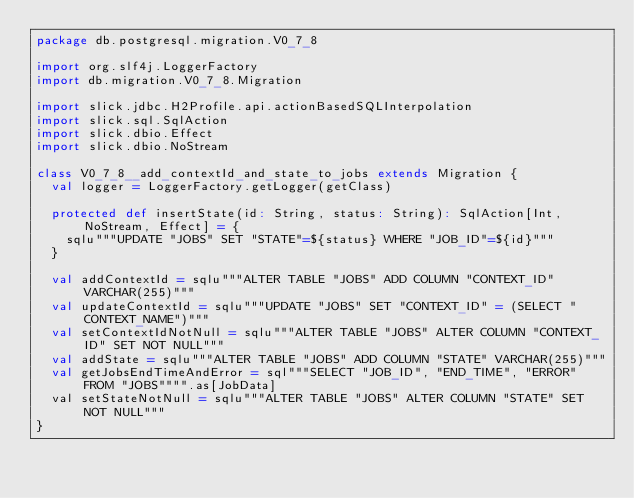<code> <loc_0><loc_0><loc_500><loc_500><_Scala_>package db.postgresql.migration.V0_7_8

import org.slf4j.LoggerFactory
import db.migration.V0_7_8.Migration

import slick.jdbc.H2Profile.api.actionBasedSQLInterpolation
import slick.sql.SqlAction
import slick.dbio.Effect
import slick.dbio.NoStream

class V0_7_8__add_contextId_and_state_to_jobs extends Migration {
  val logger = LoggerFactory.getLogger(getClass)

  protected def insertState(id: String, status: String): SqlAction[Int, NoStream, Effect] = {
    sqlu"""UPDATE "JOBS" SET "STATE"=${status} WHERE "JOB_ID"=${id}"""
  }

  val addContextId = sqlu"""ALTER TABLE "JOBS" ADD COLUMN "CONTEXT_ID" VARCHAR(255)"""
  val updateContextId = sqlu"""UPDATE "JOBS" SET "CONTEXT_ID" = (SELECT "CONTEXT_NAME")"""
  val setContextIdNotNull = sqlu"""ALTER TABLE "JOBS" ALTER COLUMN "CONTEXT_ID" SET NOT NULL"""
  val addState = sqlu"""ALTER TABLE "JOBS" ADD COLUMN "STATE" VARCHAR(255)"""
  val getJobsEndTimeAndError = sql"""SELECT "JOB_ID", "END_TIME", "ERROR" FROM "JOBS"""".as[JobData]
  val setStateNotNull = sqlu"""ALTER TABLE "JOBS" ALTER COLUMN "STATE" SET NOT NULL"""
}</code> 